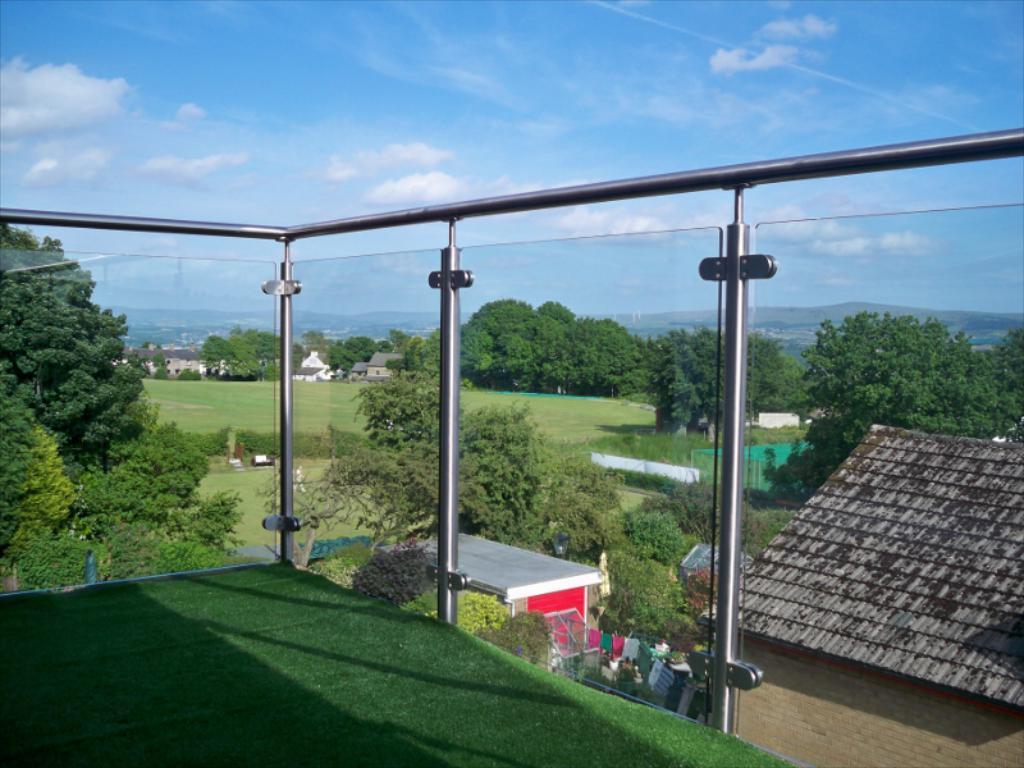How would you summarize this image in a sentence or two? In this image we can see the corridor of a building. From the corridor we can see there are buildings, trees, plants, mountains and a sky. 